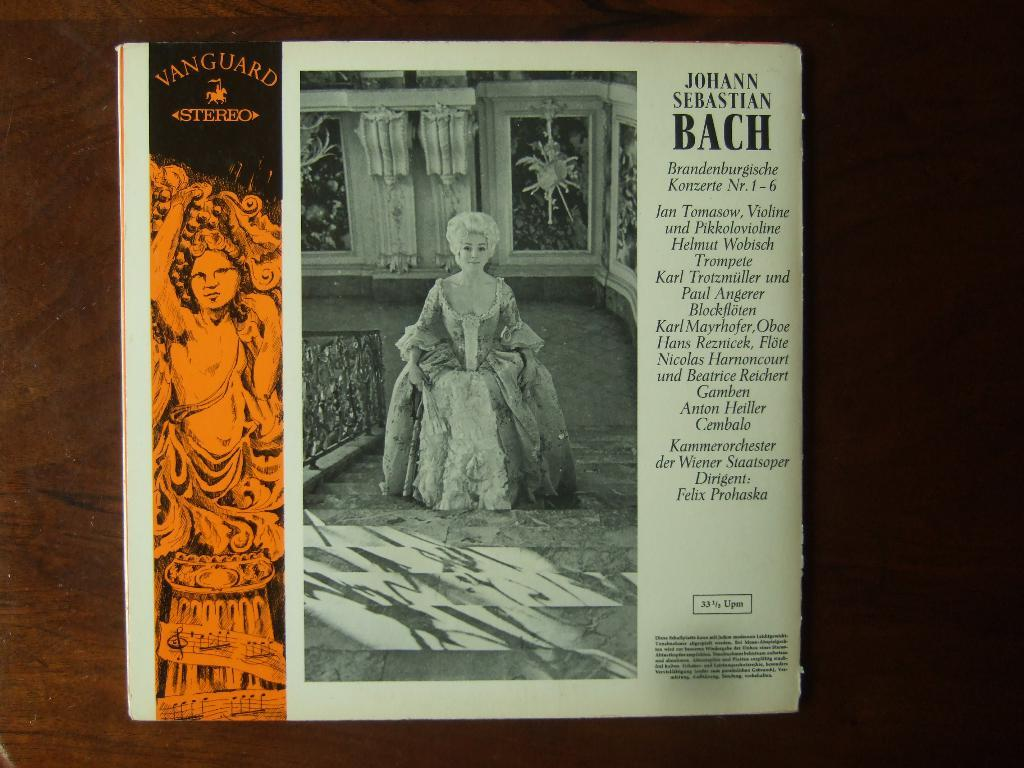Provide a one-sentence caption for the provided image. The back of a box or record label of Johann Sebastian Bach. 